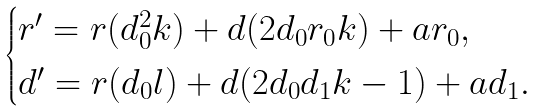<formula> <loc_0><loc_0><loc_500><loc_500>\begin{cases} r ^ { \prime } = r ( d _ { 0 } ^ { 2 } k ) + d ( 2 d _ { 0 } r _ { 0 } k ) + a r _ { 0 } , \\ d ^ { \prime } = r ( d _ { 0 } l ) + d ( 2 d _ { 0 } d _ { 1 } k - 1 ) + a d _ { 1 } . \end{cases}</formula> 